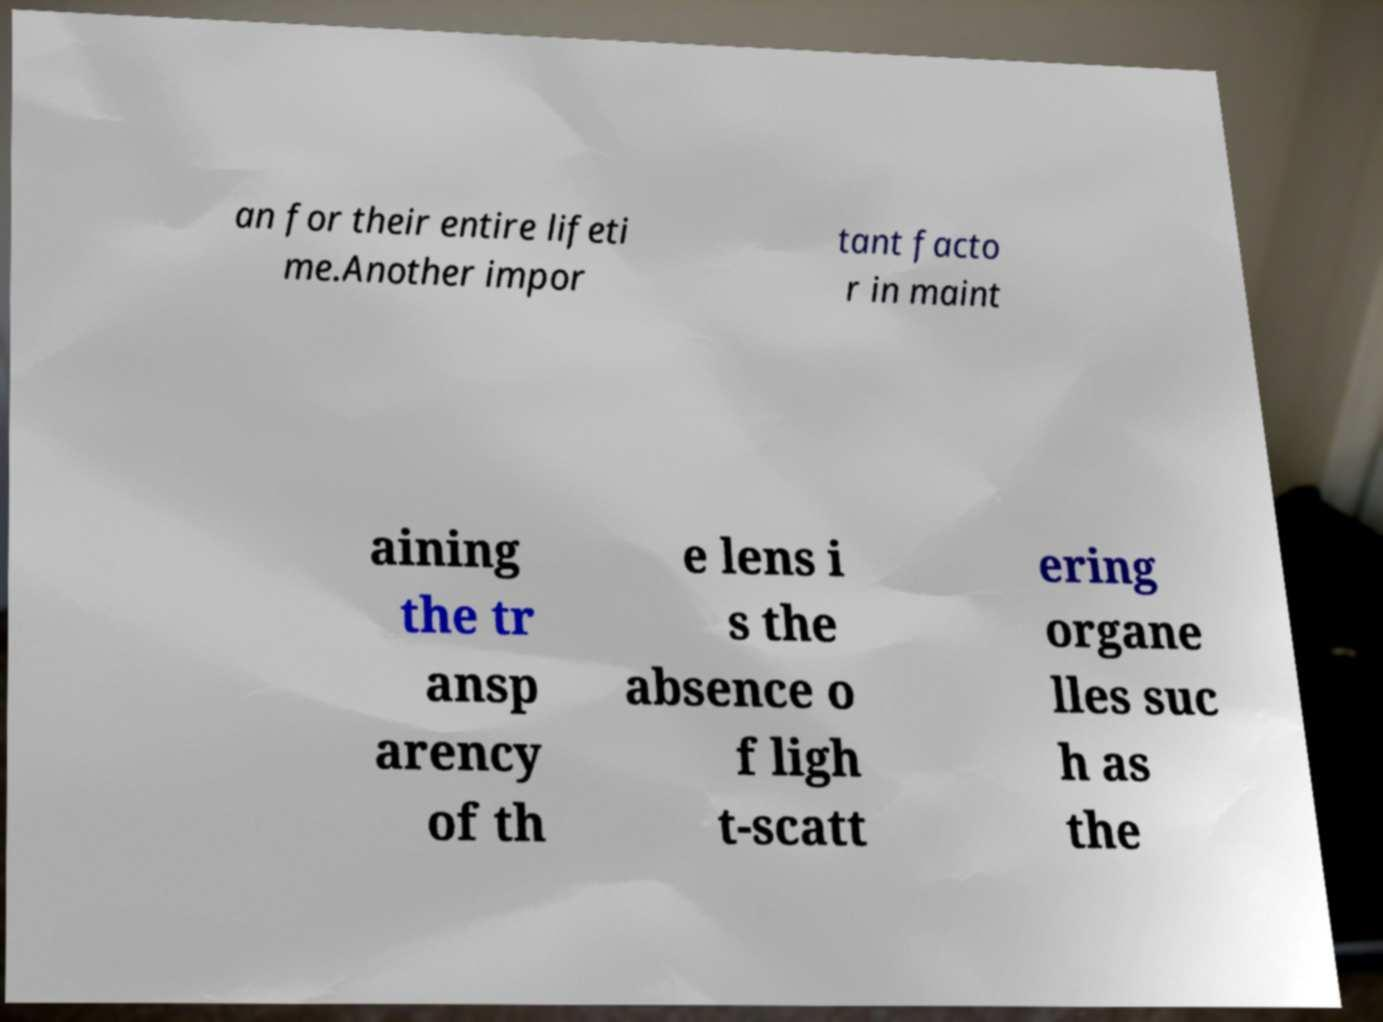Please identify and transcribe the text found in this image. an for their entire lifeti me.Another impor tant facto r in maint aining the tr ansp arency of th e lens i s the absence o f ligh t-scatt ering organe lles suc h as the 